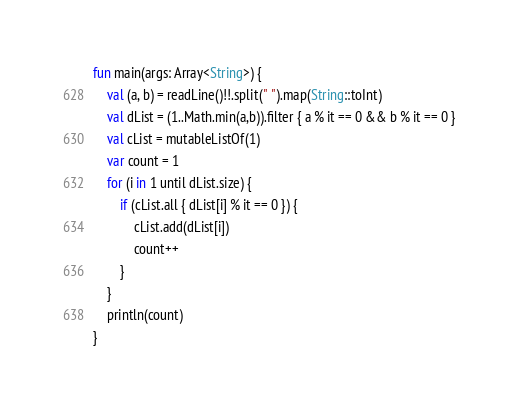Convert code to text. <code><loc_0><loc_0><loc_500><loc_500><_Kotlin_>fun main(args: Array<String>) {
    val (a, b) = readLine()!!.split(" ").map(String::toInt)
    val dList = (1..Math.min(a,b)).filter { a % it == 0 && b % it == 0 }
    val cList = mutableListOf(1)
    var count = 1
    for (i in 1 until dList.size) {
        if (cList.all { dList[i] % it == 0 }) {
            cList.add(dList[i])
            count++
        }
    }
    println(count)
}</code> 